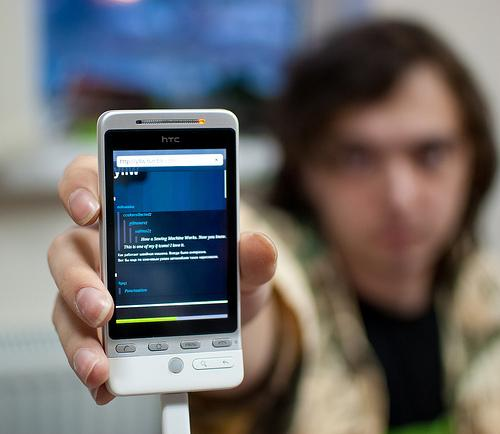Describe any visible object interactions in the image. The man is holding the cell phone with one hand, interacting with the phone by gripping it and potentially pressing buttons. Analyze the sentiment conveyed by the image. The image conveys a neutral sentiment, as it primarily focuses on a man holding a cell phone without showing much emotion or context. What is the man doing in the image, and describe his appearance with a few words. A Caucasian man is holding a white and gray HTC cell phone with one hand, and he is wearing a light-colored coat and a black shirt underneath. Determine the quality of the image based on the visibility and clarity of the objects captured. The image quality is generally good, with most objects well-defined, but some parts, such as the man's face and his shirt's pattern, appear blurred or unclear. State what type of phone is in the image and describe its visual elements. The image shows a white and gray HTC cell phone with a blue screen, gray buttons, call button, speaker, microphone, and a silver HTC logo. Identify the primary object of focus in the image and provide a brief description of its appearance. The main object in the image is a white and gray HTC cell phone held by a man, featuring a large blue screen, call button, speaker, and microphone. What type of phone is the man holding in the picture? HTC cell phone Identify the position of the home button on the smartphone. Below the blue screen What action is the man in the image performing? Holding a cell phone What is the color and brand of the phone being held by the man? White and gray, HTC What is the color of the man's undershirt? Black Describe the appearance of the man's hair in the image. The man's hair is not clearly visible, as the image focuses more on the cell phone. What color is the stripe on the man's shirt? Green Describe the event occurring in this image. A man is holding up a white and gray HTC cell phone while displaying the blue screen to the viewer. Can you find a woman holding a cell phone in the image? The image only contains information about a man holding a cell phone, not a woman. This instruction would confuse a person looking for a female subject in the image when there isn't one. Is there an orange power button in the image? The image has a "foggy translucent power button," but there is no mention of it being orange. This would cause the person to look for a power button with the wrong color, making the instruction misleading. Determine the number of fingers visible in the image. Multiple fingers are visible, but the exact number is not clear. Write a sentence describing the person holding the phone. There is a Caucasian male wearing a patterned shirt and a black undershirt, holding a white and gray HTC cell phone. Which of the following items is blurred in the image: phone, man's face, power button? man's face Which of these options is correct about the man's attire: (a) wearing a light-colored coat, (b) wearing a black coat, (c) wearing a dark-colored coat? (a) wearing a light-colored coat Does the white and gray cell phone have a gold logo? The image mentions a silver logo on the phone, not a gold logo. As gold and silver are distinct colors, this instruction is misleading because it's asking the person to look for an incorrect color of the logo. Can you find a small dog in the image? There is no mention of a small dog, or any animals for that matter, in the image. This instruction would be misleading because it's asking the person to look for an object that doesn't exist in the image. What is the color of the screen on the cell phone?  Blue What noteworthy feature is on the phone screen?  A green download progress bar Identify the object located at the top of the cell phone.  Speaker for ear Can you read any text on the phone in the image? No, there is no text visible. Describe the power button's appearance in the image. Foggy and translucent Is the man in the image wearing glasses? There is no mention of the man in the image wearing glasses. This instruction is misleading because it's asking the person to look for an attribute on the man's face that is not in the image. What are the colors of the buttons below the blue screen on the smartphone? Gray Can you see a red stripe on a man's shirt? There is a green stripe on the man's shirt mentioned, but there is no mention of a red stripe in the image. This instruction is misleading because it's asking the person to look for a color that doesn't exist on the man's shirt. 